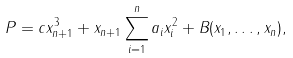Convert formula to latex. <formula><loc_0><loc_0><loc_500><loc_500>P = c x _ { n + 1 } ^ { 3 } + x _ { n + 1 } \sum _ { i = 1 } ^ { n } a _ { i } x _ { i } ^ { 2 } + B ( x _ { 1 } , \dots , x _ { n } ) ,</formula> 